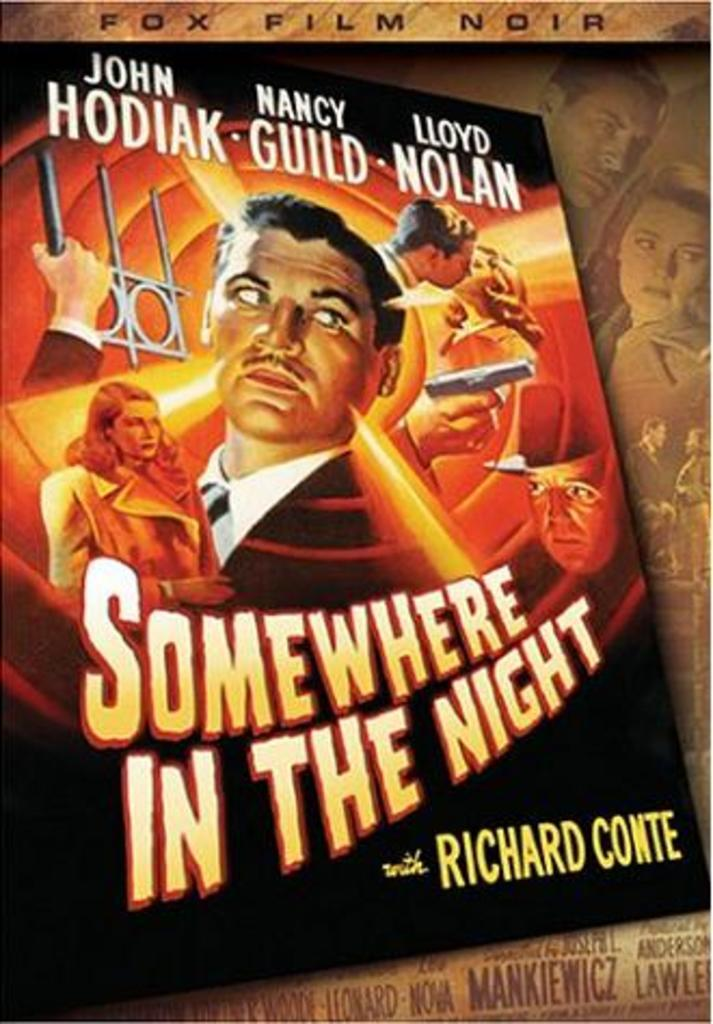<image>
Share a concise interpretation of the image provided. A cover from the movie Somewhere in the Night. 